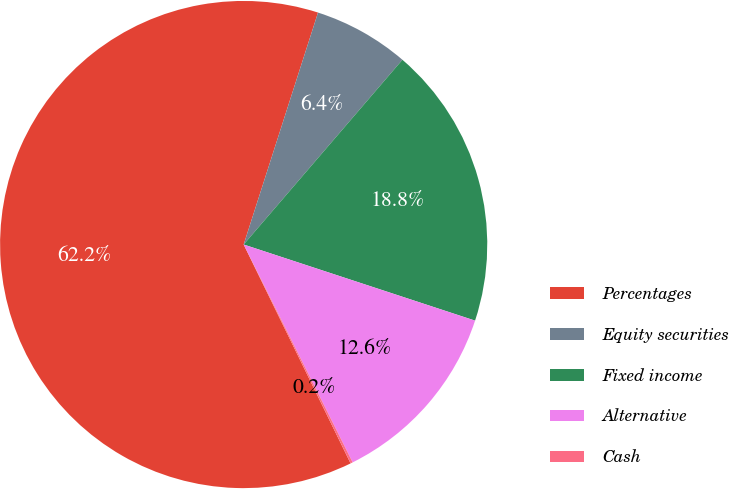Convert chart to OTSL. <chart><loc_0><loc_0><loc_500><loc_500><pie_chart><fcel>Percentages<fcel>Equity securities<fcel>Fixed income<fcel>Alternative<fcel>Cash<nl><fcel>62.17%<fcel>6.36%<fcel>18.76%<fcel>12.56%<fcel>0.15%<nl></chart> 